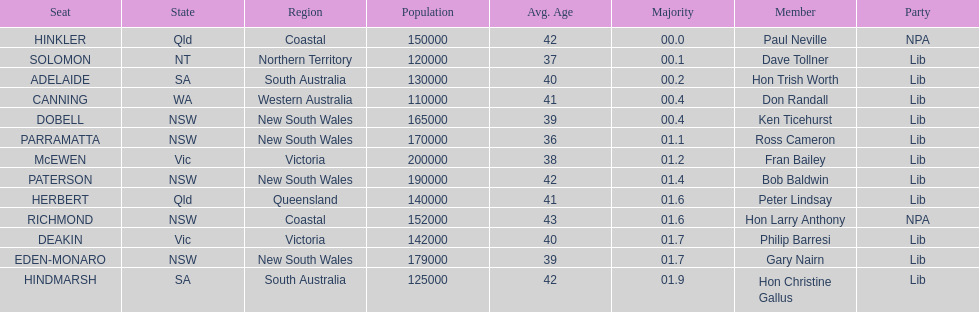What is the difference in majority between hindmarsh and hinkler? 01.9. 